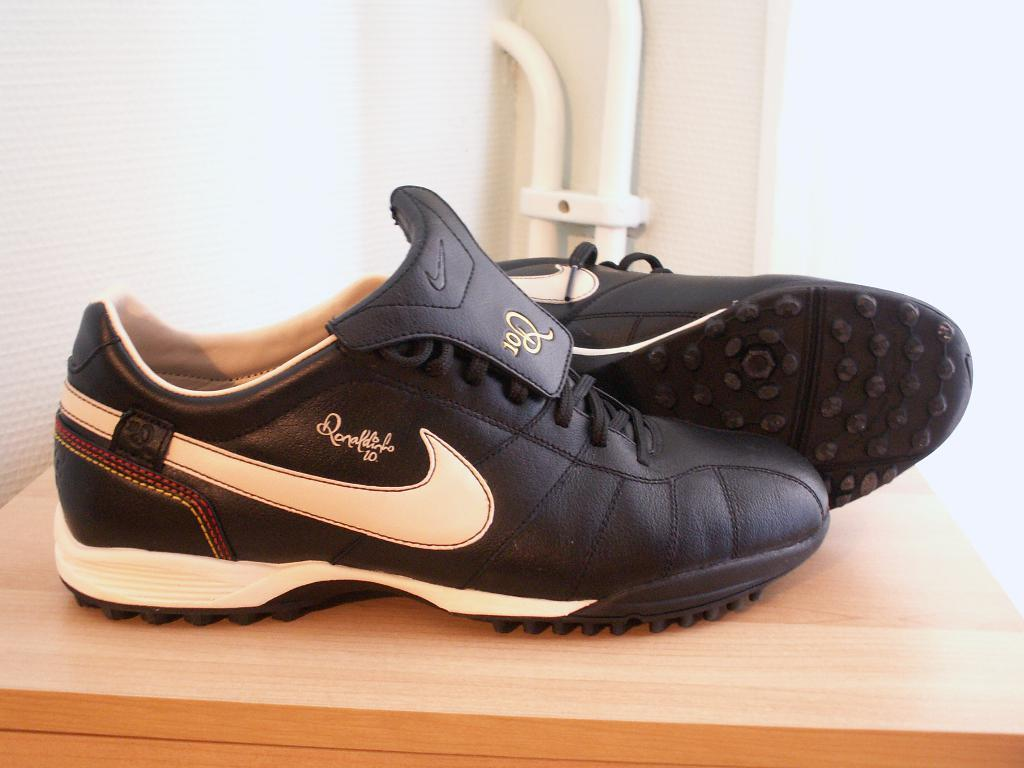What type of footwear is visible in the image? There are shoes in the image. What color are the shoes? The shoes are black in color. Where are the shoes placed in the image? The shoes are placed on a wooden box. What can be seen in the background of the image? There is a wall in the background of the image. What type of weather can be seen at the seashore in the image? There is no seashore present in the image, and therefore no weather can be observed. 